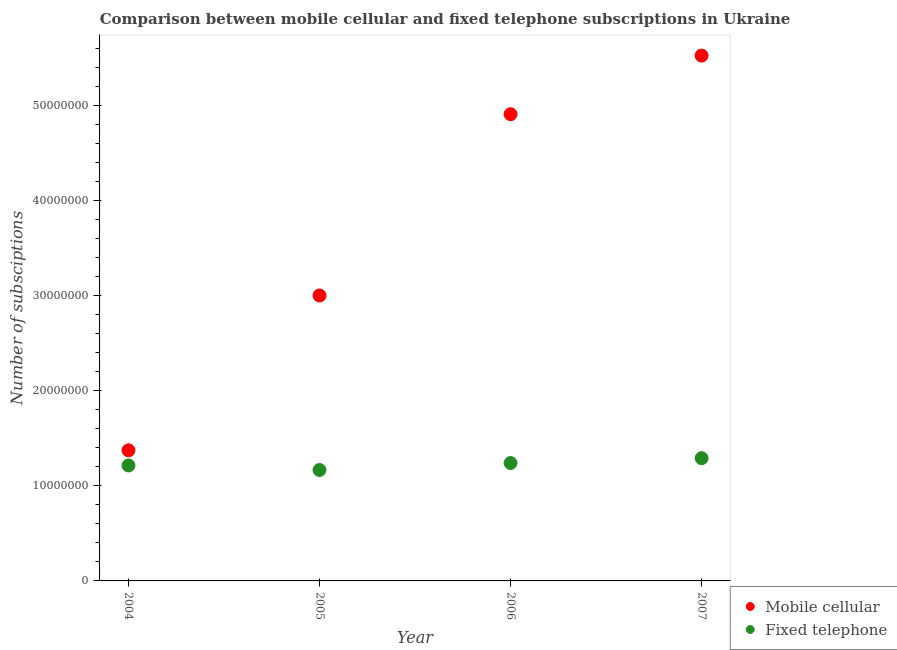What is the number of mobile cellular subscriptions in 2006?
Your answer should be very brief. 4.91e+07. Across all years, what is the maximum number of mobile cellular subscriptions?
Your answer should be compact. 5.52e+07. Across all years, what is the minimum number of fixed telephone subscriptions?
Keep it short and to the point. 1.17e+07. What is the total number of fixed telephone subscriptions in the graph?
Your answer should be very brief. 4.91e+07. What is the difference between the number of fixed telephone subscriptions in 2004 and that in 2007?
Give a very brief answer. -7.64e+05. What is the difference between the number of fixed telephone subscriptions in 2006 and the number of mobile cellular subscriptions in 2005?
Your response must be concise. -1.76e+07. What is the average number of fixed telephone subscriptions per year?
Make the answer very short. 1.23e+07. In the year 2006, what is the difference between the number of mobile cellular subscriptions and number of fixed telephone subscriptions?
Make the answer very short. 3.67e+07. What is the ratio of the number of mobile cellular subscriptions in 2004 to that in 2007?
Offer a terse response. 0.25. What is the difference between the highest and the second highest number of fixed telephone subscriptions?
Provide a short and direct response. 5.09e+05. What is the difference between the highest and the lowest number of fixed telephone subscriptions?
Your response must be concise. 1.24e+06. In how many years, is the number of mobile cellular subscriptions greater than the average number of mobile cellular subscriptions taken over all years?
Your response must be concise. 2. Is the sum of the number of fixed telephone subscriptions in 2004 and 2005 greater than the maximum number of mobile cellular subscriptions across all years?
Keep it short and to the point. No. Does the number of fixed telephone subscriptions monotonically increase over the years?
Your response must be concise. No. How many dotlines are there?
Your answer should be very brief. 2. How many years are there in the graph?
Provide a short and direct response. 4. What is the difference between two consecutive major ticks on the Y-axis?
Offer a terse response. 1.00e+07. Does the graph contain any zero values?
Give a very brief answer. No. Where does the legend appear in the graph?
Make the answer very short. Bottom right. What is the title of the graph?
Give a very brief answer. Comparison between mobile cellular and fixed telephone subscriptions in Ukraine. Does "Overweight" appear as one of the legend labels in the graph?
Your answer should be compact. No. What is the label or title of the X-axis?
Your answer should be very brief. Year. What is the label or title of the Y-axis?
Ensure brevity in your answer.  Number of subsciptions. What is the Number of subsciptions of Mobile cellular in 2004?
Offer a terse response. 1.37e+07. What is the Number of subsciptions of Fixed telephone in 2004?
Your response must be concise. 1.21e+07. What is the Number of subsciptions of Mobile cellular in 2005?
Give a very brief answer. 3.00e+07. What is the Number of subsciptions in Fixed telephone in 2005?
Give a very brief answer. 1.17e+07. What is the Number of subsciptions of Mobile cellular in 2006?
Your answer should be very brief. 4.91e+07. What is the Number of subsciptions in Fixed telephone in 2006?
Provide a short and direct response. 1.24e+07. What is the Number of subsciptions of Mobile cellular in 2007?
Give a very brief answer. 5.52e+07. What is the Number of subsciptions in Fixed telephone in 2007?
Your answer should be very brief. 1.29e+07. Across all years, what is the maximum Number of subsciptions in Mobile cellular?
Your response must be concise. 5.52e+07. Across all years, what is the maximum Number of subsciptions in Fixed telephone?
Your answer should be compact. 1.29e+07. Across all years, what is the minimum Number of subsciptions in Mobile cellular?
Your answer should be compact. 1.37e+07. Across all years, what is the minimum Number of subsciptions of Fixed telephone?
Make the answer very short. 1.17e+07. What is the total Number of subsciptions in Mobile cellular in the graph?
Give a very brief answer. 1.48e+08. What is the total Number of subsciptions in Fixed telephone in the graph?
Your response must be concise. 4.91e+07. What is the difference between the Number of subsciptions of Mobile cellular in 2004 and that in 2005?
Ensure brevity in your answer.  -1.63e+07. What is the difference between the Number of subsciptions of Fixed telephone in 2004 and that in 2005?
Your answer should be compact. 4.75e+05. What is the difference between the Number of subsciptions in Mobile cellular in 2004 and that in 2006?
Provide a succinct answer. -3.53e+07. What is the difference between the Number of subsciptions in Fixed telephone in 2004 and that in 2006?
Give a very brief answer. -2.55e+05. What is the difference between the Number of subsciptions in Mobile cellular in 2004 and that in 2007?
Your answer should be very brief. -4.15e+07. What is the difference between the Number of subsciptions of Fixed telephone in 2004 and that in 2007?
Offer a very short reply. -7.64e+05. What is the difference between the Number of subsciptions of Mobile cellular in 2005 and that in 2006?
Provide a succinct answer. -1.91e+07. What is the difference between the Number of subsciptions of Fixed telephone in 2005 and that in 2006?
Your answer should be very brief. -7.31e+05. What is the difference between the Number of subsciptions in Mobile cellular in 2005 and that in 2007?
Keep it short and to the point. -2.52e+07. What is the difference between the Number of subsciptions of Fixed telephone in 2005 and that in 2007?
Give a very brief answer. -1.24e+06. What is the difference between the Number of subsciptions in Mobile cellular in 2006 and that in 2007?
Give a very brief answer. -6.16e+06. What is the difference between the Number of subsciptions of Fixed telephone in 2006 and that in 2007?
Your answer should be compact. -5.09e+05. What is the difference between the Number of subsciptions of Mobile cellular in 2004 and the Number of subsciptions of Fixed telephone in 2005?
Give a very brief answer. 2.07e+06. What is the difference between the Number of subsciptions of Mobile cellular in 2004 and the Number of subsciptions of Fixed telephone in 2006?
Offer a very short reply. 1.34e+06. What is the difference between the Number of subsciptions in Mobile cellular in 2004 and the Number of subsciptions in Fixed telephone in 2007?
Provide a short and direct response. 8.29e+05. What is the difference between the Number of subsciptions of Mobile cellular in 2005 and the Number of subsciptions of Fixed telephone in 2006?
Keep it short and to the point. 1.76e+07. What is the difference between the Number of subsciptions of Mobile cellular in 2005 and the Number of subsciptions of Fixed telephone in 2007?
Your answer should be very brief. 1.71e+07. What is the difference between the Number of subsciptions of Mobile cellular in 2006 and the Number of subsciptions of Fixed telephone in 2007?
Offer a very short reply. 3.62e+07. What is the average Number of subsciptions in Mobile cellular per year?
Keep it short and to the point. 3.70e+07. What is the average Number of subsciptions of Fixed telephone per year?
Keep it short and to the point. 1.23e+07. In the year 2004, what is the difference between the Number of subsciptions of Mobile cellular and Number of subsciptions of Fixed telephone?
Offer a terse response. 1.59e+06. In the year 2005, what is the difference between the Number of subsciptions in Mobile cellular and Number of subsciptions in Fixed telephone?
Provide a succinct answer. 1.83e+07. In the year 2006, what is the difference between the Number of subsciptions of Mobile cellular and Number of subsciptions of Fixed telephone?
Give a very brief answer. 3.67e+07. In the year 2007, what is the difference between the Number of subsciptions in Mobile cellular and Number of subsciptions in Fixed telephone?
Give a very brief answer. 4.23e+07. What is the ratio of the Number of subsciptions of Mobile cellular in 2004 to that in 2005?
Your answer should be compact. 0.46. What is the ratio of the Number of subsciptions of Fixed telephone in 2004 to that in 2005?
Ensure brevity in your answer.  1.04. What is the ratio of the Number of subsciptions in Mobile cellular in 2004 to that in 2006?
Ensure brevity in your answer.  0.28. What is the ratio of the Number of subsciptions in Fixed telephone in 2004 to that in 2006?
Make the answer very short. 0.98. What is the ratio of the Number of subsciptions of Mobile cellular in 2004 to that in 2007?
Your answer should be very brief. 0.25. What is the ratio of the Number of subsciptions in Fixed telephone in 2004 to that in 2007?
Your answer should be very brief. 0.94. What is the ratio of the Number of subsciptions in Mobile cellular in 2005 to that in 2006?
Offer a very short reply. 0.61. What is the ratio of the Number of subsciptions in Fixed telephone in 2005 to that in 2006?
Make the answer very short. 0.94. What is the ratio of the Number of subsciptions of Mobile cellular in 2005 to that in 2007?
Your response must be concise. 0.54. What is the ratio of the Number of subsciptions in Fixed telephone in 2005 to that in 2007?
Offer a very short reply. 0.9. What is the ratio of the Number of subsciptions in Mobile cellular in 2006 to that in 2007?
Your answer should be compact. 0.89. What is the ratio of the Number of subsciptions of Fixed telephone in 2006 to that in 2007?
Make the answer very short. 0.96. What is the difference between the highest and the second highest Number of subsciptions in Mobile cellular?
Make the answer very short. 6.16e+06. What is the difference between the highest and the second highest Number of subsciptions of Fixed telephone?
Provide a succinct answer. 5.09e+05. What is the difference between the highest and the lowest Number of subsciptions of Mobile cellular?
Offer a very short reply. 4.15e+07. What is the difference between the highest and the lowest Number of subsciptions of Fixed telephone?
Offer a very short reply. 1.24e+06. 